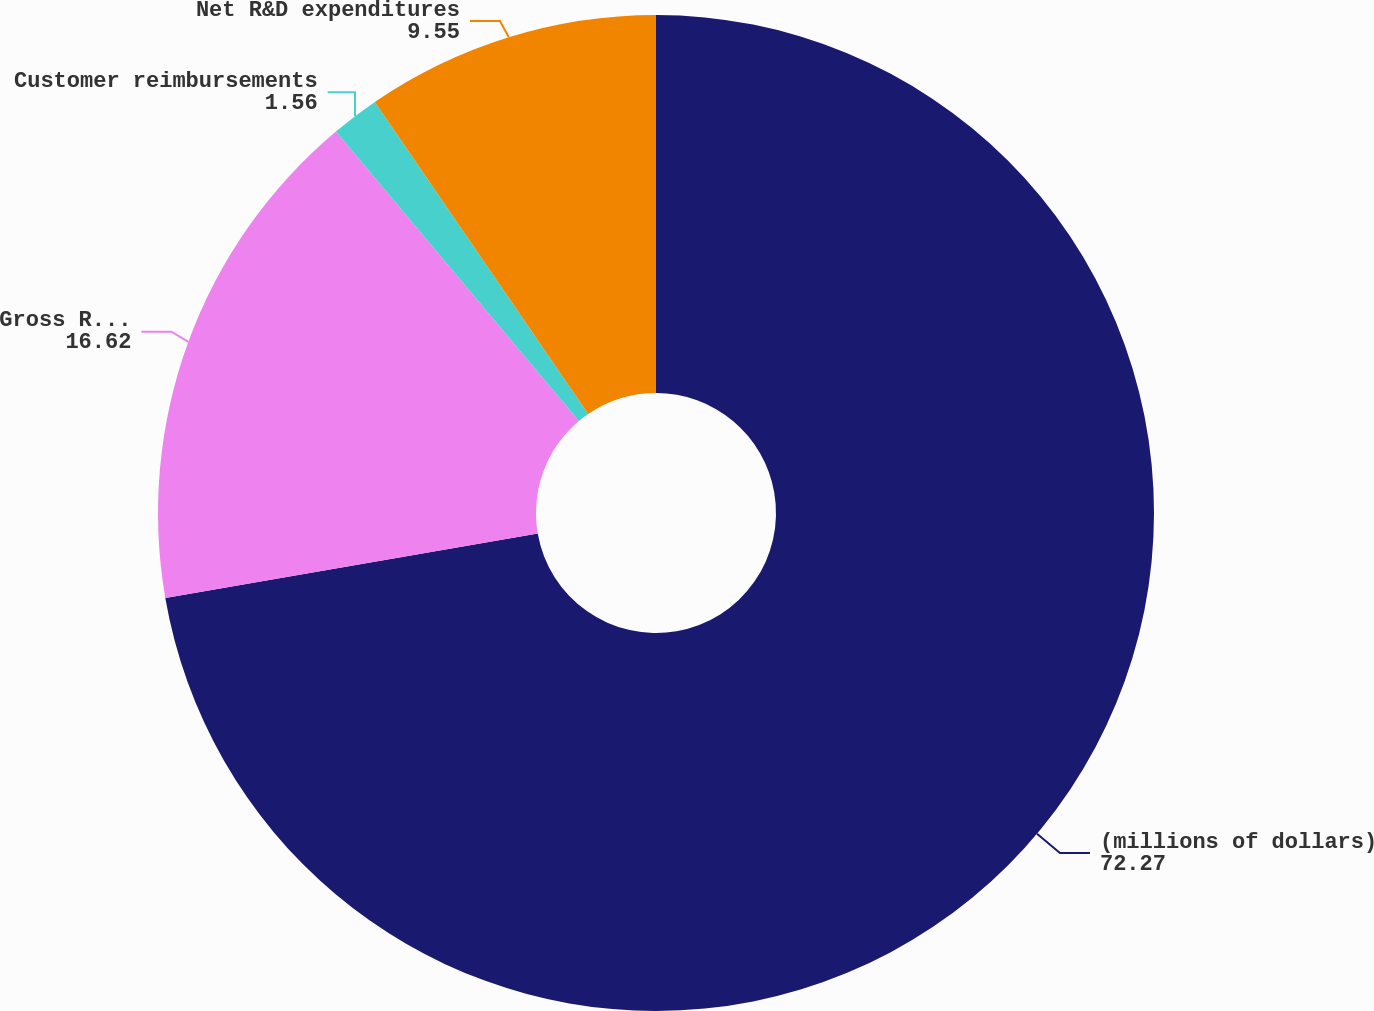<chart> <loc_0><loc_0><loc_500><loc_500><pie_chart><fcel>(millions of dollars)<fcel>Gross R&D expenditures<fcel>Customer reimbursements<fcel>Net R&D expenditures<nl><fcel>72.27%<fcel>16.62%<fcel>1.56%<fcel>9.55%<nl></chart> 